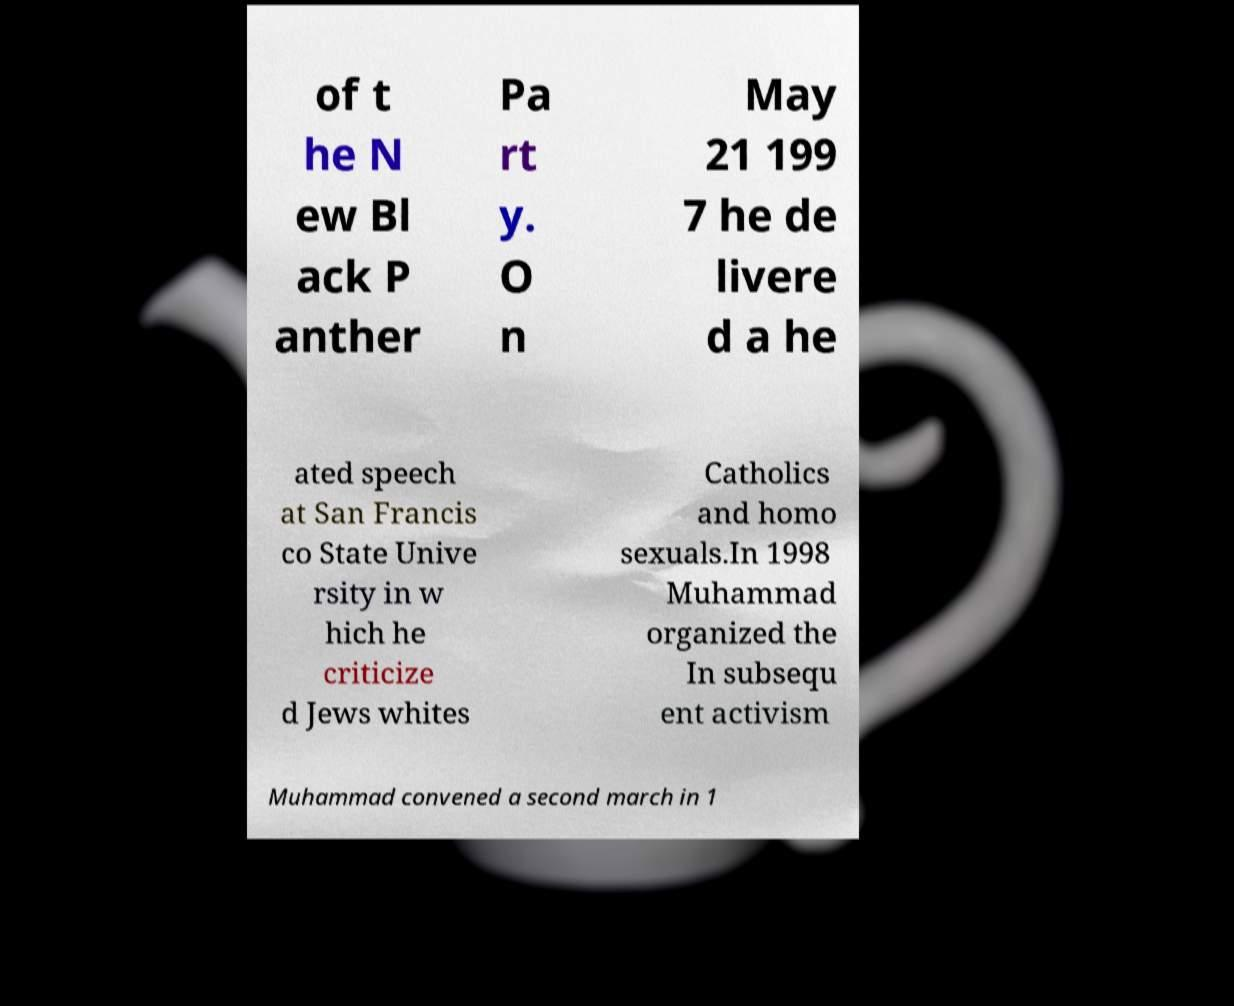Could you extract and type out the text from this image? of t he N ew Bl ack P anther Pa rt y. O n May 21 199 7 he de livere d a he ated speech at San Francis co State Unive rsity in w hich he criticize d Jews whites Catholics and homo sexuals.In 1998 Muhammad organized the In subsequ ent activism Muhammad convened a second march in 1 